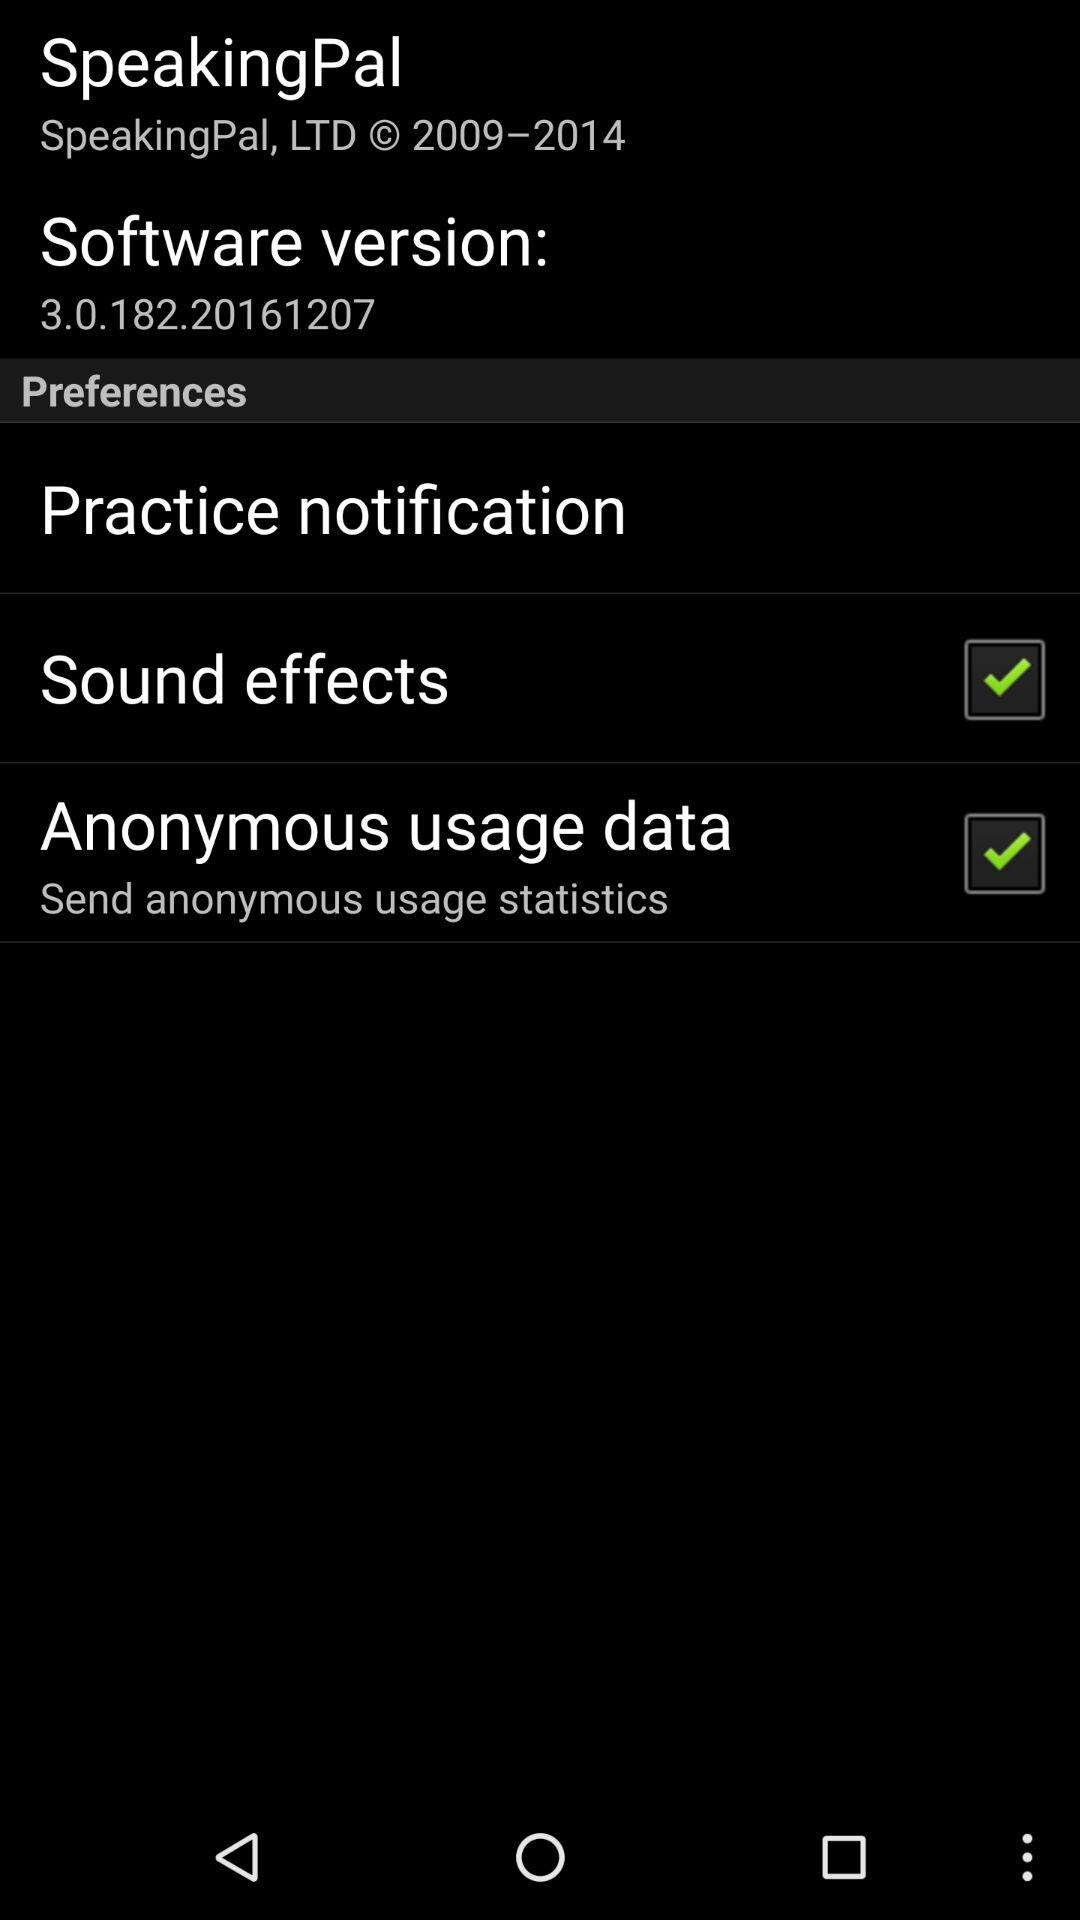What is the software version? The version is 3.0.182.20161207. 